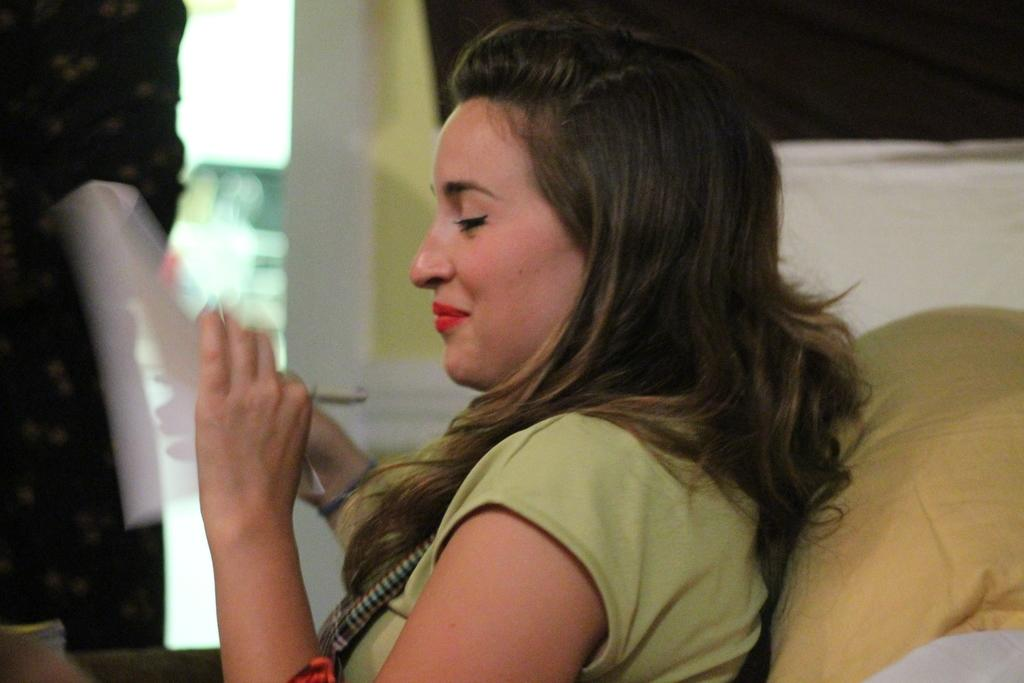Who is the main subject in the image? There is a woman in the image. In which direction is the woman facing? The woman is facing the left side of the image. What is the woman holding in the image? The woman is holding an object. What type of beginner's lesson is the woman attending in the image? There is no indication in the image that the woman is attending a beginner's lesson or any lesson at all. --- Facts: 1. There is a car in the image. 2. The car is red. 3. The car has four wheels. 4. There is a road in the image. 5. The road is paved. Absurd Topics: parrot, ocean, dance Conversation: What is the main subject in the image? There is a car in the image. What color is the car? The car is red. How many wheels does the car have? The car has four wheels. What type of surface is the car on in the image? There is a road in the image, and it is paved. Reasoning: Let's think step by step in order to produce the conversation. We start by identifying the main subject in the image, which is the car. Then, we describe its color and the number of wheels it has, which are details provided in the facts. Finally, we mention the type of surface the car is on, which is a paved road. Absurd Question/Answer: Can you see a parrot flying over the ocean in the image? There is no parrot or ocean present in the image; it features a red car on a paved road. 